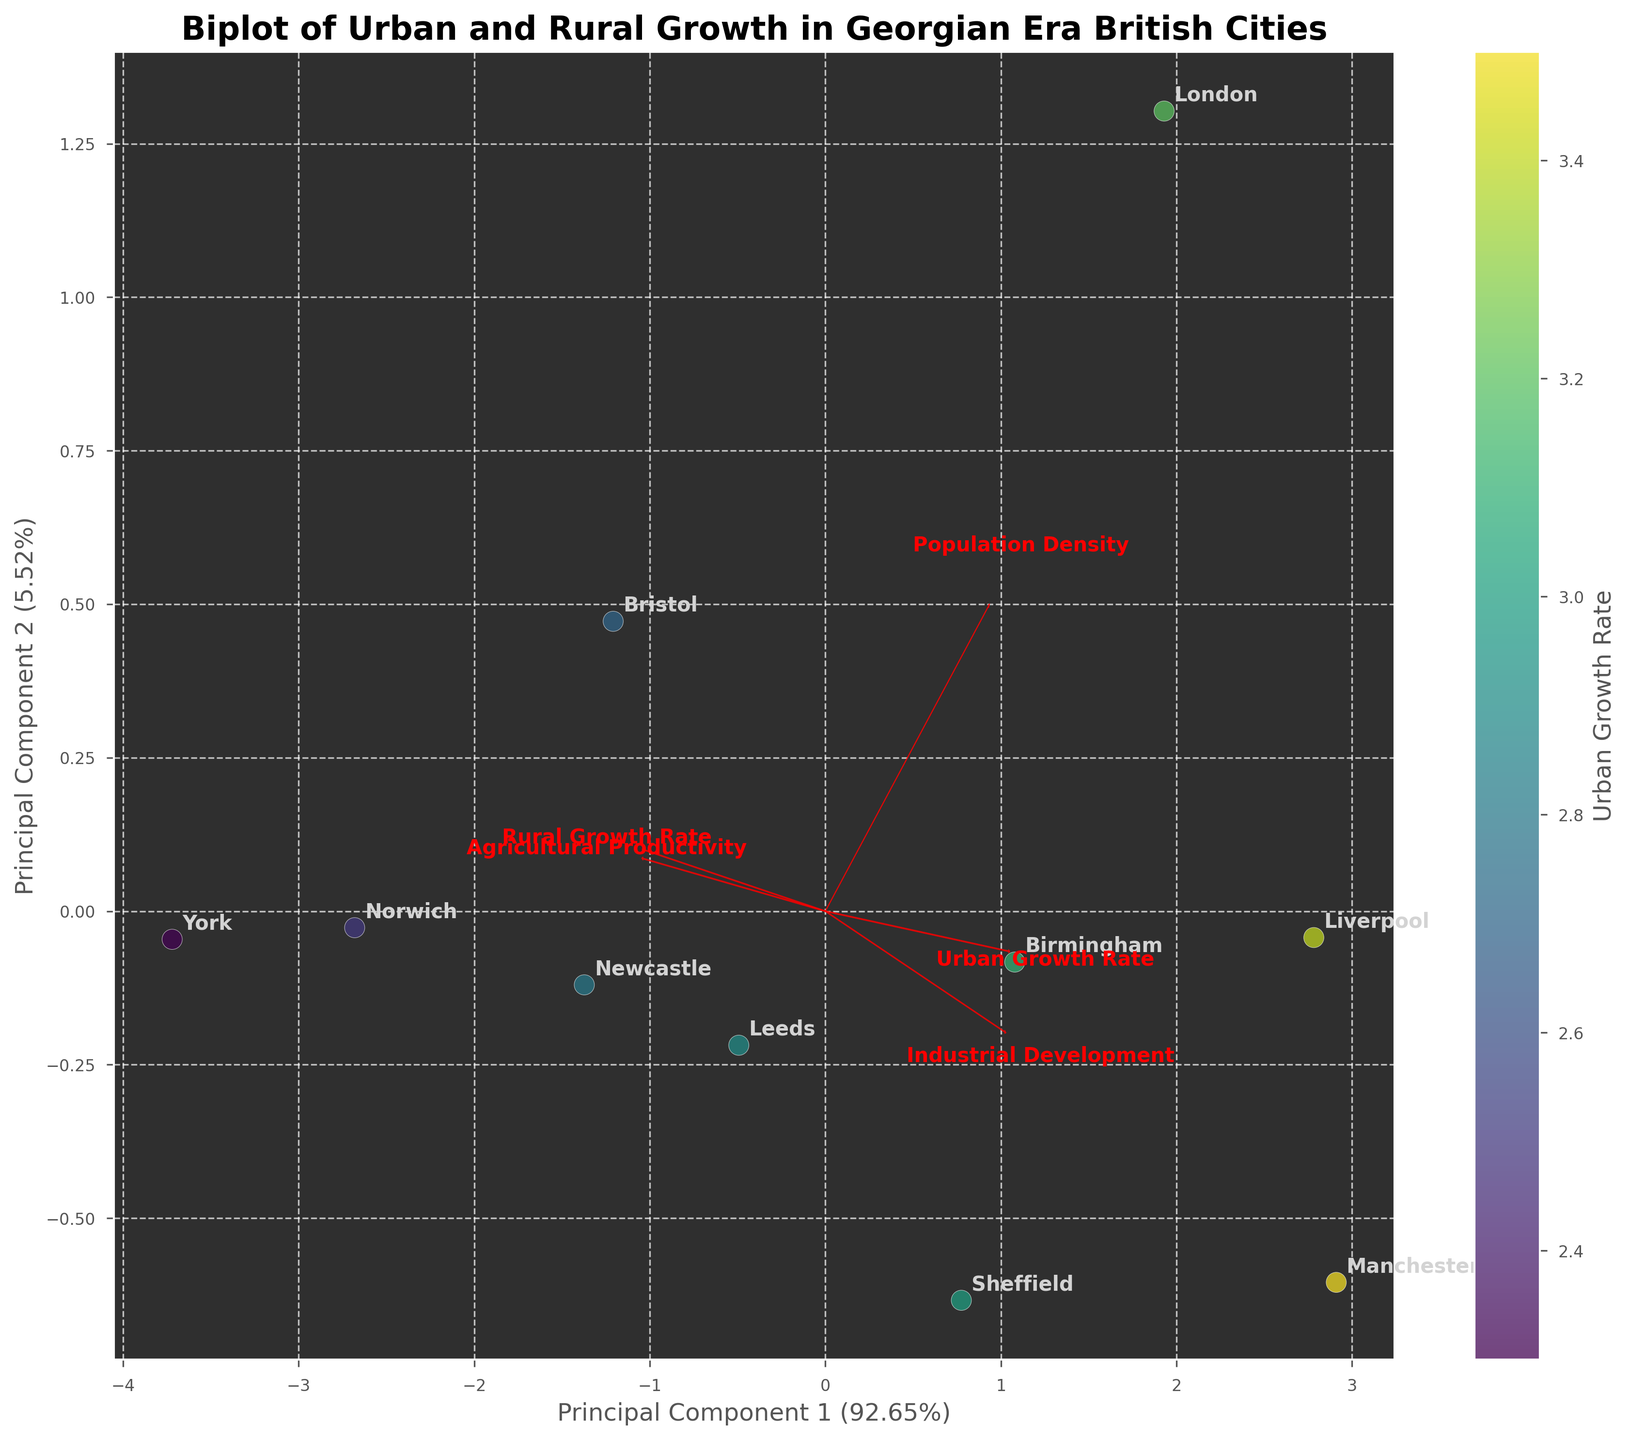How many data points are shown in the plot? Identify the number of cities (data points) represented by the labels on the plot. Each city is a data point.
Answer: 10 Which principal component accounts for a higher variation in the data? Look at the Axis labels that show the explained variance percentage. Compare the percentages of Principal Component 1 and Principal Component 2.
Answer: Principal Component 1 Which city has the highest Urban Growth Rate? Observe the color gradient of the data points where a higher Urban Growth Rate should appear in a more intense color according to the colorbar. Identify the city label with that color.
Answer: Manchester Which feature vectors are plotted as red arrows? Identify and enumerate the feature labels that are shown as red arrows on the biplot. These labels represent the variables' contribution to the principal components.
Answer: Urban Growth Rate, Rural Growth Rate, Population Density, Industrial Development, Agricultural Productivity What city is closest to the feature vector for Industrial Development? Look at the positions of the data points in relation to the direction of the Industrial Development feature vector. Identify the city label closest to this vector.
Answer: Manchester Which city has the greatest distance in the plot from the city of York? Locate the positions of all the city labels. Measure the visual distance between York and each of the other city points.
Answer: London How does Liverpool's Urban Growth Rate compare to its Rural Growth Rate? Find the data point labeled "Liverpool" and, if necessary, cross-reference with color indicating the Urban Growth Rate. Compare with arrow directions for Urban and Rural Growth Rates.
Answer: Urban Growth Rate is higher Which features are most closely aligned with Principal Component 1? Observe the feature vectors (arrows) and see which ones have the highest component along the Principal Component 1 axis.
Answer: Industrial Development What is the relationship between Agricultural Productivity and Urban Growth Rate in the cities plotted? Consider the position of the feature vectors for Agricultural Productivity and Urban Growth Rate. Check if the arrows are pointing in similar or opposing directions to interpret their relationship.
Answer: Generally opposing directions Which city is most likely to have a balanced growth between its urban and rural areas? Look for a data point (city) that is nearly equidistant in direction and magnitude from the vectors for Urban and Rural Growth Rates.
Answer: Newcastle 